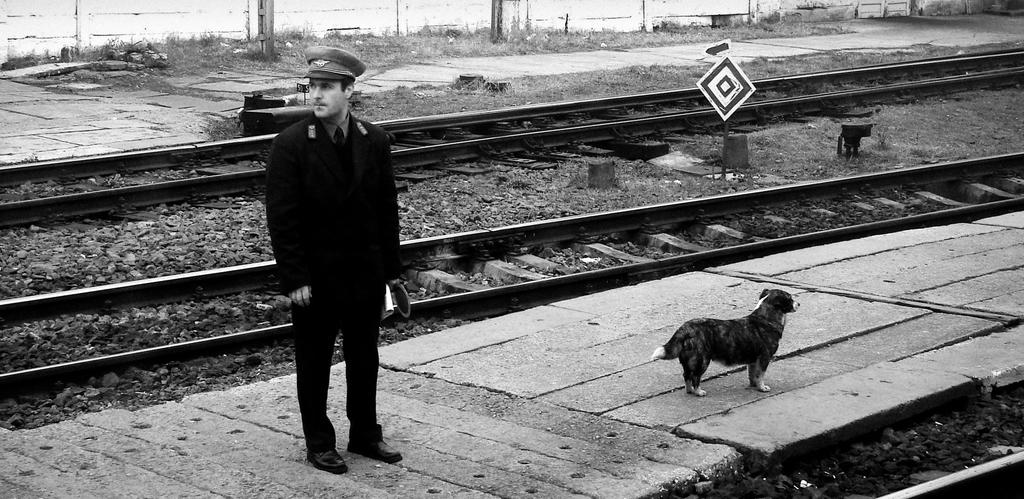What is the color scheme of the image? The image is black and white. Who or what can be seen in the image? There is a man and a dog in the image. Where are the man and dog located? They are on a walkway in the image. What else can be seen in the image? Train tracks, a board, a pole, and a platform are visible in the image. What type of juice is the man drinking from the cup in the image? There is no cup or juice present in the image. What hour of the day is depicted in the image? The image does not provide any information about the time of day, as it is in black and white and does not include any clocks or time-related details. 